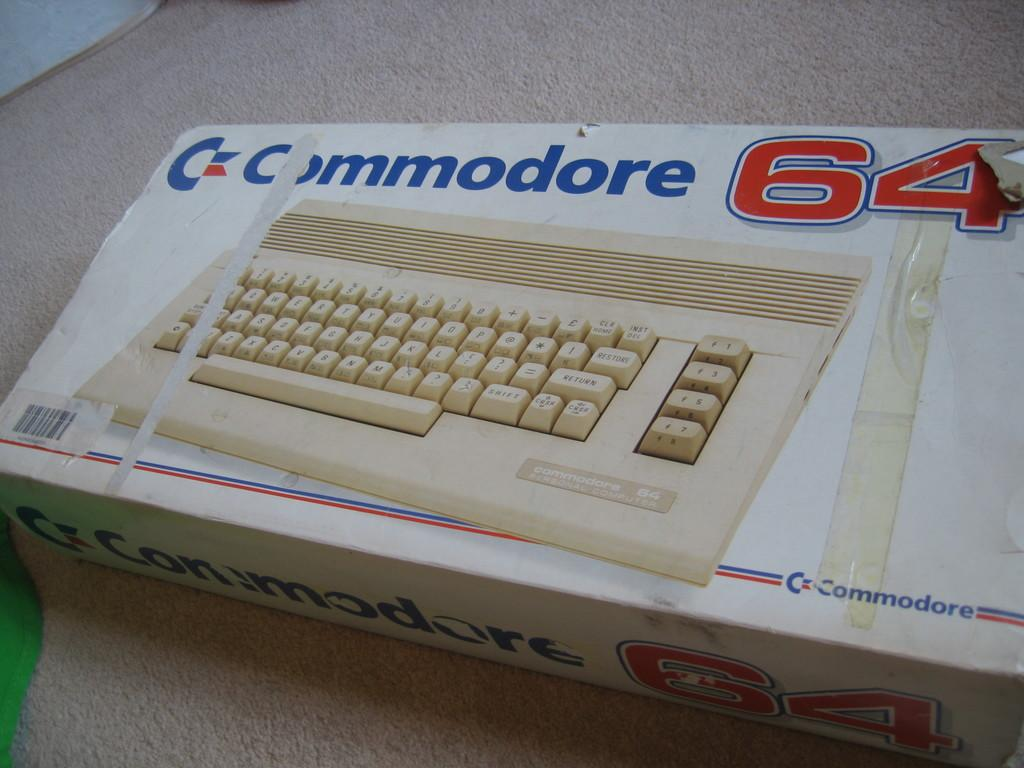Provide a one-sentence caption for the provided image. a box with a keyboard picture on it that looks old and taped, brand name is Commodore 64. 